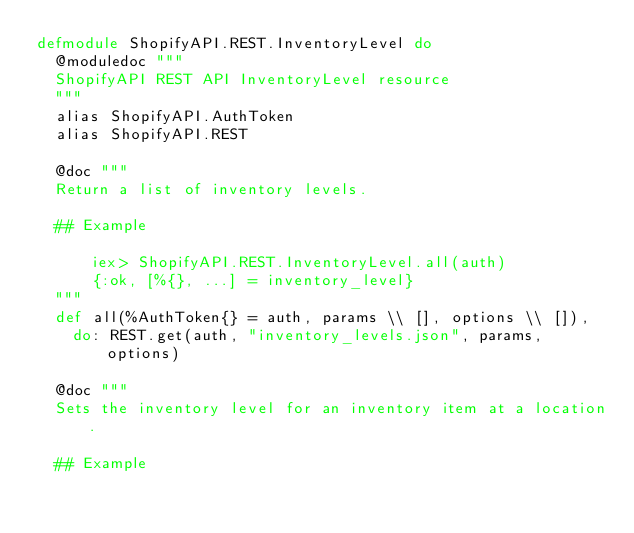Convert code to text. <code><loc_0><loc_0><loc_500><loc_500><_Elixir_>defmodule ShopifyAPI.REST.InventoryLevel do
  @moduledoc """
  ShopifyAPI REST API InventoryLevel resource
  """
  alias ShopifyAPI.AuthToken
  alias ShopifyAPI.REST

  @doc """
  Return a list of inventory levels.

  ## Example

      iex> ShopifyAPI.REST.InventoryLevel.all(auth)
      {:ok, [%{}, ...] = inventory_level}
  """
  def all(%AuthToken{} = auth, params \\ [], options \\ []),
    do: REST.get(auth, "inventory_levels.json", params, options)

  @doc """
  Sets the inventory level for an inventory item at a location.

  ## Example
</code> 